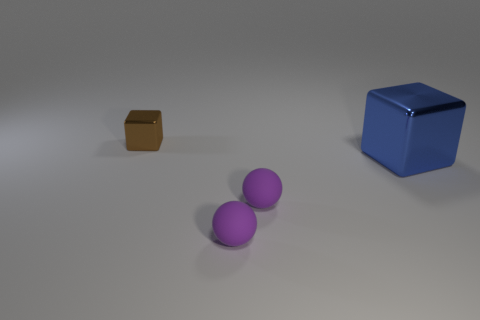Add 4 tiny objects. How many objects exist? 8 Add 2 large blue metallic cubes. How many large blue metallic cubes exist? 3 Subtract 0 yellow cylinders. How many objects are left? 4 Subtract all large blue objects. Subtract all matte spheres. How many objects are left? 1 Add 1 brown blocks. How many brown blocks are left? 2 